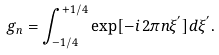Convert formula to latex. <formula><loc_0><loc_0><loc_500><loc_500>g _ { n } = \int _ { - 1 / 4 } ^ { + 1 / 4 } \exp [ - i \, 2 \pi n \xi ^ { ^ { \prime } } ] d \xi ^ { ^ { \prime } } .</formula> 